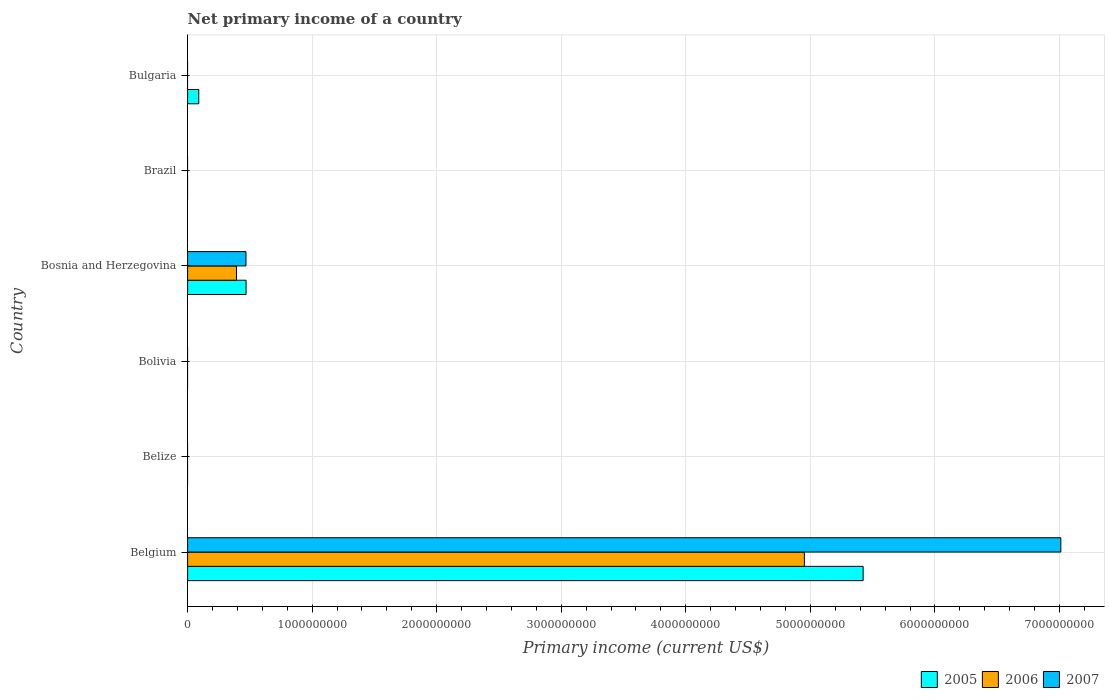How many bars are there on the 4th tick from the top?
Provide a short and direct response. 0. How many bars are there on the 3rd tick from the bottom?
Provide a succinct answer. 0. What is the label of the 5th group of bars from the top?
Your answer should be very brief. Belize. Across all countries, what is the maximum primary income in 2007?
Offer a very short reply. 7.01e+09. Across all countries, what is the minimum primary income in 2005?
Keep it short and to the point. 0. What is the total primary income in 2007 in the graph?
Ensure brevity in your answer.  7.48e+09. What is the difference between the primary income in 2007 in Belgium and that in Bosnia and Herzegovina?
Provide a short and direct response. 6.54e+09. What is the difference between the primary income in 2007 in Belize and the primary income in 2006 in Belgium?
Offer a very short reply. -4.95e+09. What is the average primary income in 2005 per country?
Offer a very short reply. 9.97e+08. What is the difference between the primary income in 2005 and primary income in 2006 in Belgium?
Keep it short and to the point. 4.72e+08. Is the primary income in 2005 in Belgium less than that in Bosnia and Herzegovina?
Offer a terse response. No. What is the difference between the highest and the second highest primary income in 2005?
Your response must be concise. 4.95e+09. What is the difference between the highest and the lowest primary income in 2006?
Provide a succinct answer. 4.95e+09. Is the sum of the primary income in 2005 in Belgium and Bulgaria greater than the maximum primary income in 2007 across all countries?
Your response must be concise. No. Does the graph contain any zero values?
Ensure brevity in your answer.  Yes. Does the graph contain grids?
Ensure brevity in your answer.  Yes. Where does the legend appear in the graph?
Provide a short and direct response. Bottom right. How many legend labels are there?
Give a very brief answer. 3. What is the title of the graph?
Keep it short and to the point. Net primary income of a country. What is the label or title of the X-axis?
Your answer should be compact. Primary income (current US$). What is the label or title of the Y-axis?
Provide a succinct answer. Country. What is the Primary income (current US$) of 2005 in Belgium?
Provide a succinct answer. 5.42e+09. What is the Primary income (current US$) in 2006 in Belgium?
Ensure brevity in your answer.  4.95e+09. What is the Primary income (current US$) of 2007 in Belgium?
Give a very brief answer. 7.01e+09. What is the Primary income (current US$) in 2005 in Belize?
Make the answer very short. 0. What is the Primary income (current US$) of 2005 in Bolivia?
Make the answer very short. 0. What is the Primary income (current US$) of 2006 in Bolivia?
Offer a very short reply. 0. What is the Primary income (current US$) in 2005 in Bosnia and Herzegovina?
Your answer should be compact. 4.70e+08. What is the Primary income (current US$) of 2006 in Bosnia and Herzegovina?
Provide a succinct answer. 3.92e+08. What is the Primary income (current US$) of 2007 in Bosnia and Herzegovina?
Your response must be concise. 4.69e+08. What is the Primary income (current US$) in 2006 in Brazil?
Your response must be concise. 0. What is the Primary income (current US$) of 2005 in Bulgaria?
Make the answer very short. 8.96e+07. Across all countries, what is the maximum Primary income (current US$) in 2005?
Your response must be concise. 5.42e+09. Across all countries, what is the maximum Primary income (current US$) of 2006?
Give a very brief answer. 4.95e+09. Across all countries, what is the maximum Primary income (current US$) of 2007?
Ensure brevity in your answer.  7.01e+09. What is the total Primary income (current US$) in 2005 in the graph?
Ensure brevity in your answer.  5.98e+09. What is the total Primary income (current US$) of 2006 in the graph?
Ensure brevity in your answer.  5.34e+09. What is the total Primary income (current US$) in 2007 in the graph?
Provide a short and direct response. 7.48e+09. What is the difference between the Primary income (current US$) in 2005 in Belgium and that in Bosnia and Herzegovina?
Provide a short and direct response. 4.95e+09. What is the difference between the Primary income (current US$) of 2006 in Belgium and that in Bosnia and Herzegovina?
Your answer should be compact. 4.56e+09. What is the difference between the Primary income (current US$) of 2007 in Belgium and that in Bosnia and Herzegovina?
Your response must be concise. 6.54e+09. What is the difference between the Primary income (current US$) of 2005 in Belgium and that in Bulgaria?
Ensure brevity in your answer.  5.33e+09. What is the difference between the Primary income (current US$) of 2005 in Bosnia and Herzegovina and that in Bulgaria?
Give a very brief answer. 3.80e+08. What is the difference between the Primary income (current US$) in 2005 in Belgium and the Primary income (current US$) in 2006 in Bosnia and Herzegovina?
Offer a terse response. 5.03e+09. What is the difference between the Primary income (current US$) of 2005 in Belgium and the Primary income (current US$) of 2007 in Bosnia and Herzegovina?
Offer a terse response. 4.96e+09. What is the difference between the Primary income (current US$) in 2006 in Belgium and the Primary income (current US$) in 2007 in Bosnia and Herzegovina?
Your answer should be compact. 4.48e+09. What is the average Primary income (current US$) in 2005 per country?
Make the answer very short. 9.97e+08. What is the average Primary income (current US$) of 2006 per country?
Your answer should be very brief. 8.91e+08. What is the average Primary income (current US$) in 2007 per country?
Make the answer very short. 1.25e+09. What is the difference between the Primary income (current US$) in 2005 and Primary income (current US$) in 2006 in Belgium?
Your answer should be compact. 4.72e+08. What is the difference between the Primary income (current US$) in 2005 and Primary income (current US$) in 2007 in Belgium?
Ensure brevity in your answer.  -1.59e+09. What is the difference between the Primary income (current US$) in 2006 and Primary income (current US$) in 2007 in Belgium?
Your answer should be compact. -2.06e+09. What is the difference between the Primary income (current US$) in 2005 and Primary income (current US$) in 2006 in Bosnia and Herzegovina?
Your response must be concise. 7.71e+07. What is the difference between the Primary income (current US$) of 2005 and Primary income (current US$) of 2007 in Bosnia and Herzegovina?
Offer a terse response. 8.27e+05. What is the difference between the Primary income (current US$) in 2006 and Primary income (current US$) in 2007 in Bosnia and Herzegovina?
Make the answer very short. -7.62e+07. What is the ratio of the Primary income (current US$) of 2005 in Belgium to that in Bosnia and Herzegovina?
Make the answer very short. 11.55. What is the ratio of the Primary income (current US$) of 2006 in Belgium to that in Bosnia and Herzegovina?
Your response must be concise. 12.62. What is the ratio of the Primary income (current US$) in 2007 in Belgium to that in Bosnia and Herzegovina?
Your answer should be compact. 14.96. What is the ratio of the Primary income (current US$) of 2005 in Belgium to that in Bulgaria?
Make the answer very short. 60.51. What is the ratio of the Primary income (current US$) in 2005 in Bosnia and Herzegovina to that in Bulgaria?
Make the answer very short. 5.24. What is the difference between the highest and the second highest Primary income (current US$) in 2005?
Your answer should be very brief. 4.95e+09. What is the difference between the highest and the lowest Primary income (current US$) in 2005?
Provide a succinct answer. 5.42e+09. What is the difference between the highest and the lowest Primary income (current US$) in 2006?
Offer a terse response. 4.95e+09. What is the difference between the highest and the lowest Primary income (current US$) in 2007?
Offer a terse response. 7.01e+09. 